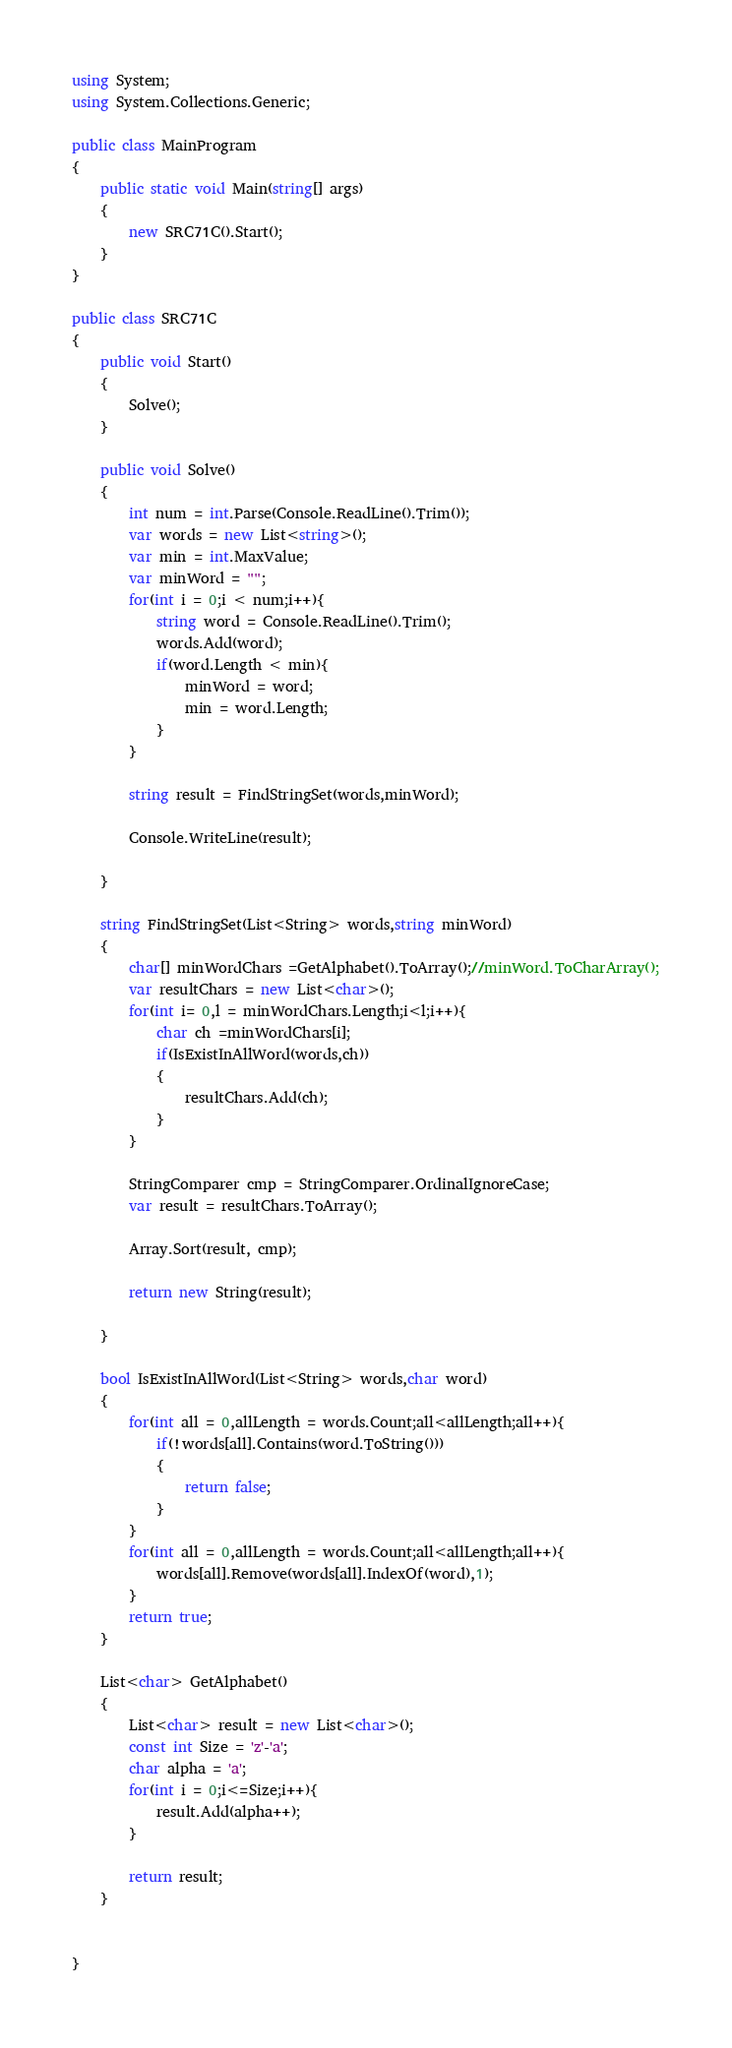Convert code to text. <code><loc_0><loc_0><loc_500><loc_500><_C#_>using System;
using System.Collections.Generic;

public class MainProgram
{
    public static void Main(string[] args)
    {
        new SRC71C().Start();
    }
}

public class SRC71C
{
    public void Start()
    {
        Solve();
    }

    public void Solve()
    {
        int num = int.Parse(Console.ReadLine().Trim());
        var words = new List<string>();
        var min = int.MaxValue;
        var minWord = "";
        for(int i = 0;i < num;i++){
            string word = Console.ReadLine().Trim();
            words.Add(word);
            if(word.Length < min){
                minWord = word;
                min = word.Length;
            }
        }

        string result = FindStringSet(words,minWord);

        Console.WriteLine(result);

    }

    string FindStringSet(List<String> words,string minWord)
    {
        char[] minWordChars =GetAlphabet().ToArray();//minWord.ToCharArray();
        var resultChars = new List<char>();
        for(int i= 0,l = minWordChars.Length;i<l;i++){
            char ch =minWordChars[i];
            if(IsExistInAllWord(words,ch))
            {
                resultChars.Add(ch);
            }
        }

        StringComparer cmp = StringComparer.OrdinalIgnoreCase;
        var result = resultChars.ToArray();

        Array.Sort(result, cmp);

        return new String(result);

    }

    bool IsExistInAllWord(List<String> words,char word)
    {
        for(int all = 0,allLength = words.Count;all<allLength;all++){
            if(!words[all].Contains(word.ToString()))
            {
                return false;
            }
        }
        for(int all = 0,allLength = words.Count;all<allLength;all++){
            words[all].Remove(words[all].IndexOf(word),1);
        }
        return true;
    }

    List<char> GetAlphabet()
    {
        List<char> result = new List<char>();
        const int Size = 'z'-'a';
        char alpha = 'a'; 
        for(int i = 0;i<=Size;i++){
            result.Add(alpha++);
        }

        return result;
    }


}</code> 